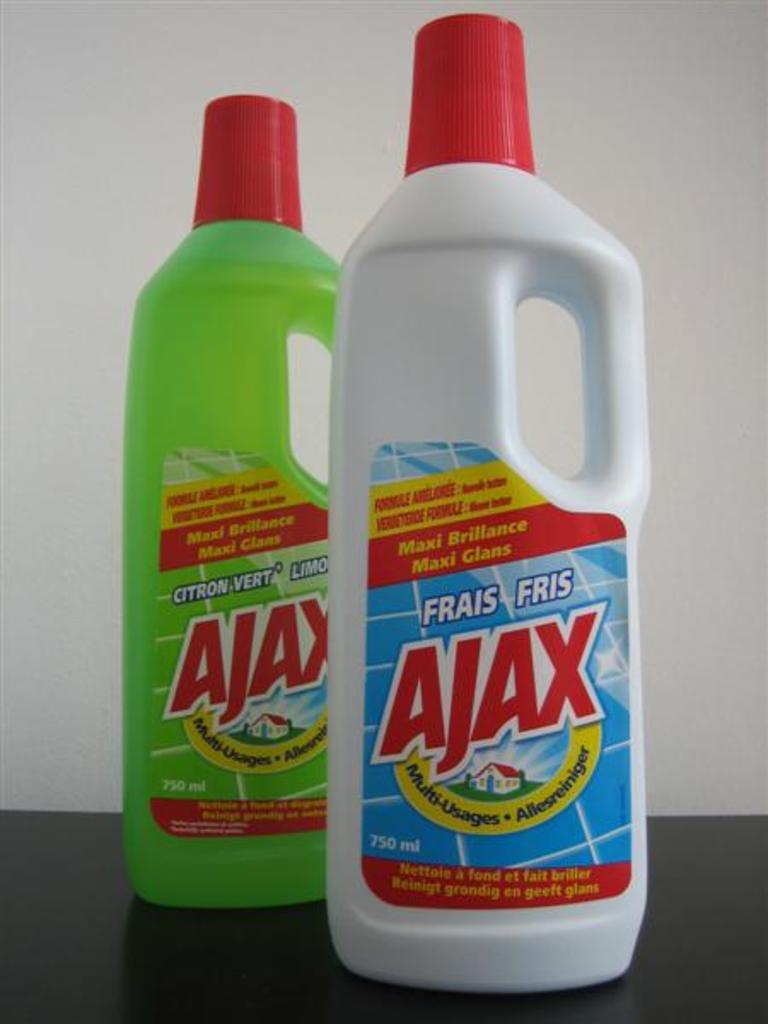What is the difference between these ajax cleaners?
Ensure brevity in your answer.  Fragrance. 